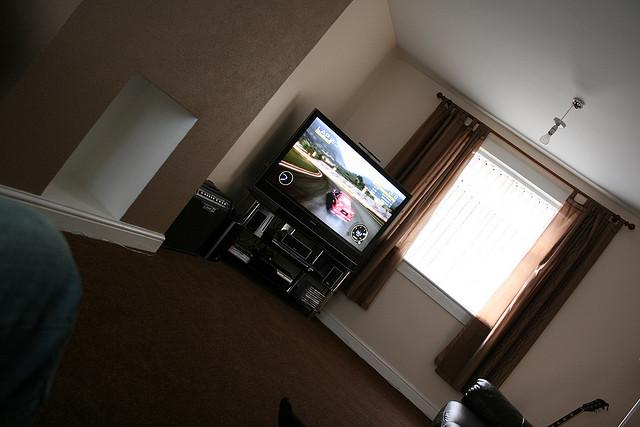What type of game is being played? racing 